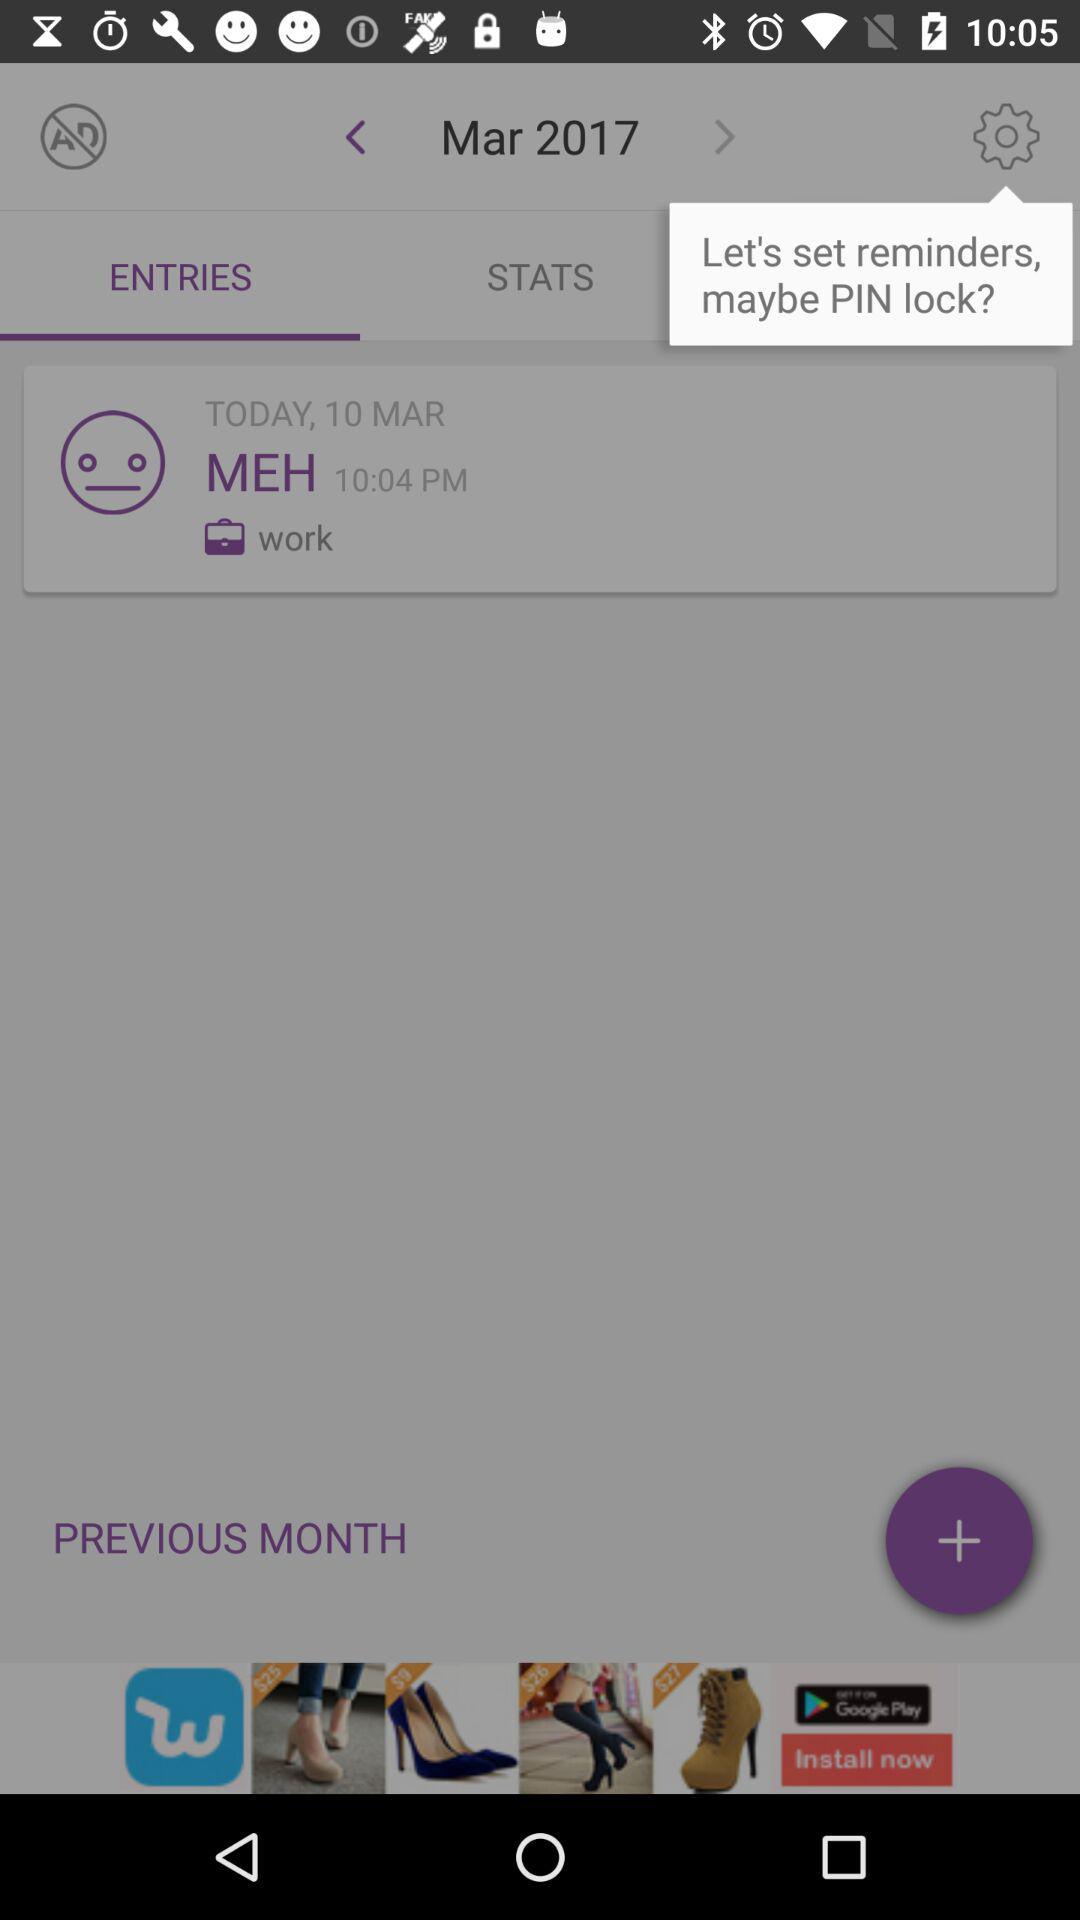What date is shown on the screen? The date shown on the screen is March 10, 2017. 